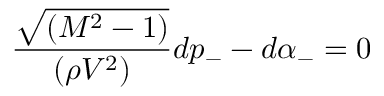Convert formula to latex. <formula><loc_0><loc_0><loc_500><loc_500>\frac { \sqrt { ( M ^ { 2 } - 1 ) } } { ( \rho V ^ { 2 } ) } d p _ { - } - d \alpha _ { - } = 0</formula> 